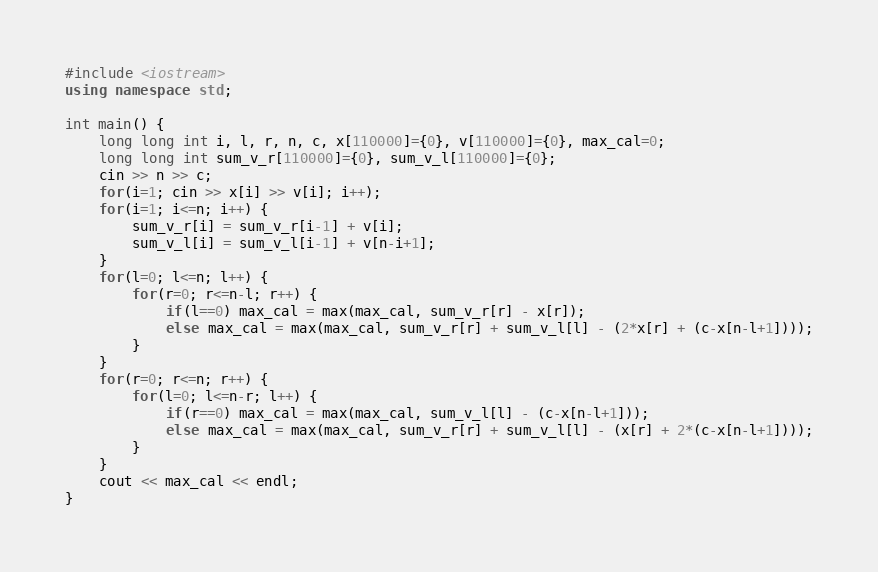Convert code to text. <code><loc_0><loc_0><loc_500><loc_500><_C++_>#include <iostream>
using namespace std;

int main() {
    long long int i, l, r, n, c, x[110000]={0}, v[110000]={0}, max_cal=0;
    long long int sum_v_r[110000]={0}, sum_v_l[110000]={0};
    cin >> n >> c;
    for(i=1; cin >> x[i] >> v[i]; i++);
    for(i=1; i<=n; i++) {
        sum_v_r[i] = sum_v_r[i-1] + v[i];
        sum_v_l[i] = sum_v_l[i-1] + v[n-i+1];
    }
    for(l=0; l<=n; l++) {
        for(r=0; r<=n-l; r++) {
            if(l==0) max_cal = max(max_cal, sum_v_r[r] - x[r]);
            else max_cal = max(max_cal, sum_v_r[r] + sum_v_l[l] - (2*x[r] + (c-x[n-l+1])));
        }
    }
    for(r=0; r<=n; r++) {
        for(l=0; l<=n-r; l++) {
            if(r==0) max_cal = max(max_cal, sum_v_l[l] - (c-x[n-l+1]));
            else max_cal = max(max_cal, sum_v_r[r] + sum_v_l[l] - (x[r] + 2*(c-x[n-l+1])));
        }
    }
    cout << max_cal << endl;
}</code> 